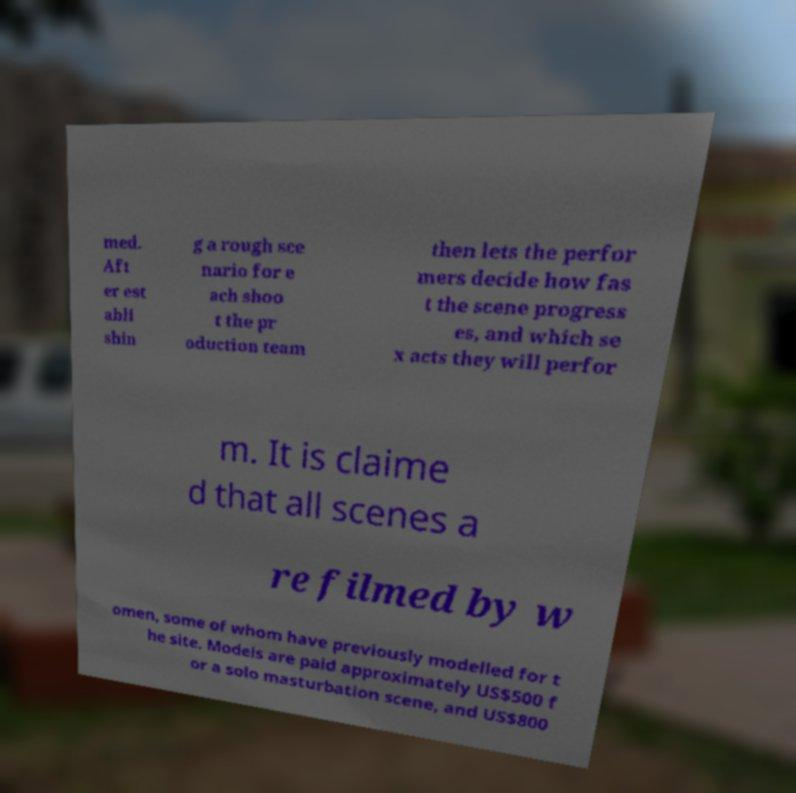Please read and relay the text visible in this image. What does it say? med. Aft er est abli shin g a rough sce nario for e ach shoo t the pr oduction team then lets the perfor mers decide how fas t the scene progress es, and which se x acts they will perfor m. It is claime d that all scenes a re filmed by w omen, some of whom have previously modelled for t he site. Models are paid approximately US$500 f or a solo masturbation scene, and US$800 